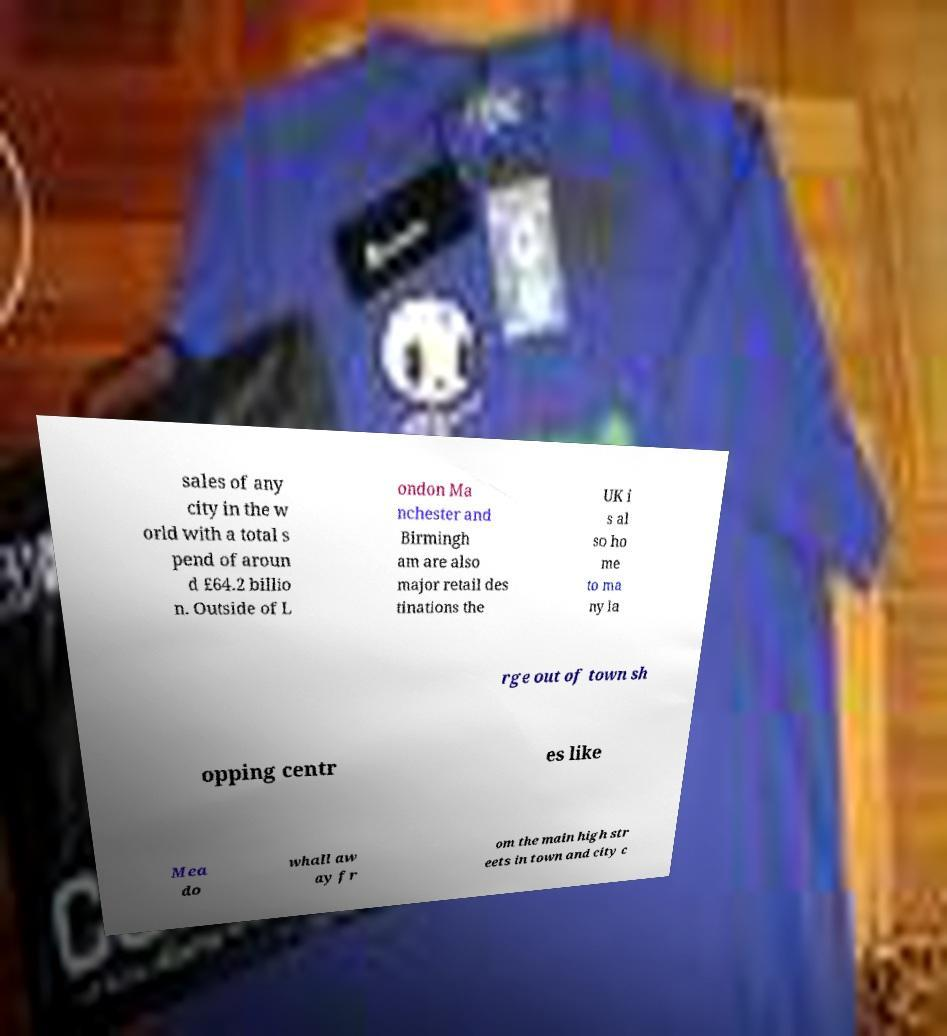What messages or text are displayed in this image? I need them in a readable, typed format. sales of any city in the w orld with a total s pend of aroun d £64.2 billio n. Outside of L ondon Ma nchester and Birmingh am are also major retail des tinations the UK i s al so ho me to ma ny la rge out of town sh opping centr es like Mea do whall aw ay fr om the main high str eets in town and city c 